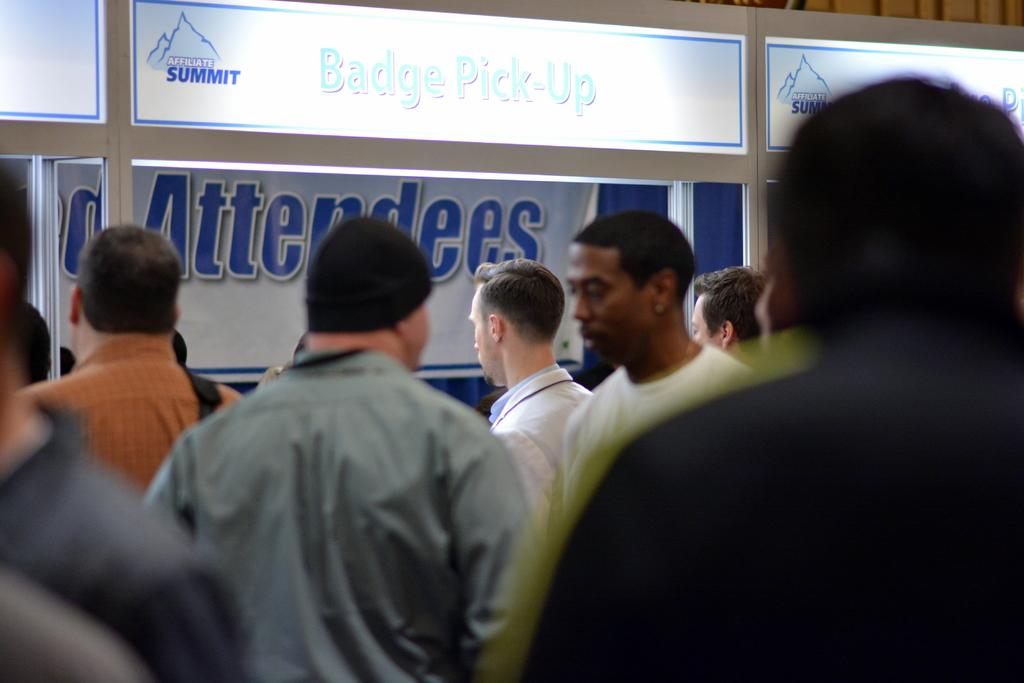How many people are in the image? There is a group of people in the image, but the exact number cannot be determined from the provided facts. What can be seen in the background of the image? In the background of the image, there are posters, a banner, a curtain, rods, and an object. Can you describe the object in the background of the image? Unfortunately, the facts do not provide enough information to describe the object in the background. What type of plate is being used to serve the quince in the image? There is no plate or quince present in the image. How does the pain affect the group of people in the image? There is no mention of pain or any emotional state in the image. 